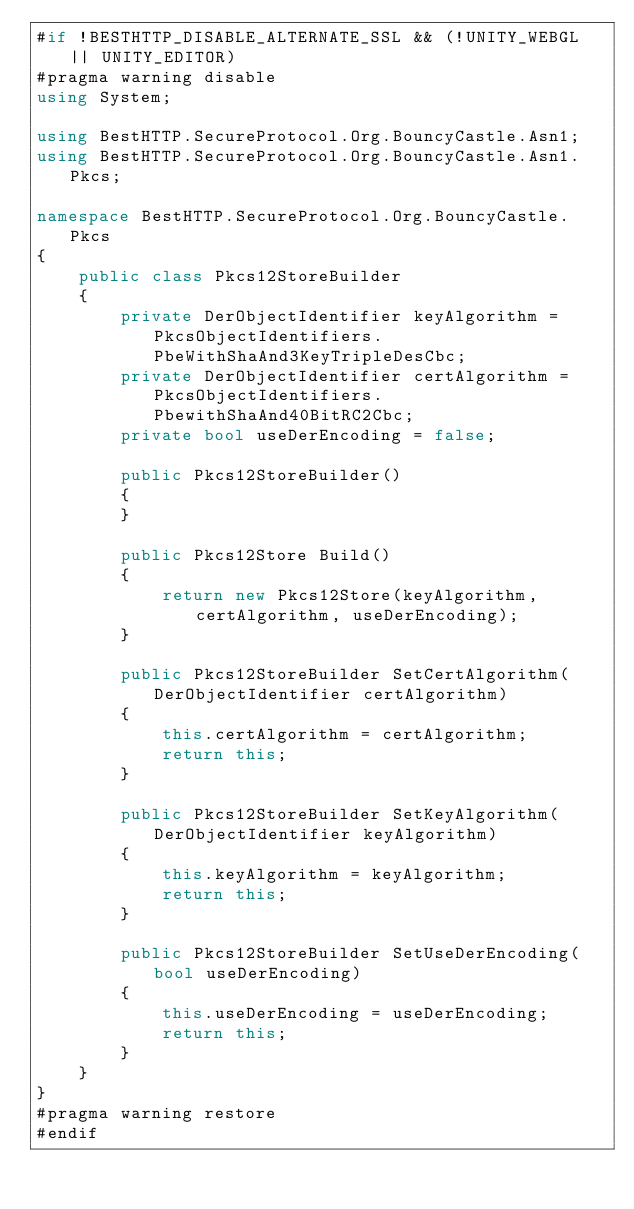<code> <loc_0><loc_0><loc_500><loc_500><_C#_>#if !BESTHTTP_DISABLE_ALTERNATE_SSL && (!UNITY_WEBGL || UNITY_EDITOR)
#pragma warning disable
using System;

using BestHTTP.SecureProtocol.Org.BouncyCastle.Asn1;
using BestHTTP.SecureProtocol.Org.BouncyCastle.Asn1.Pkcs;

namespace BestHTTP.SecureProtocol.Org.BouncyCastle.Pkcs
{
	public class Pkcs12StoreBuilder
	{
		private DerObjectIdentifier	keyAlgorithm = PkcsObjectIdentifiers.PbeWithShaAnd3KeyTripleDesCbc;
		private DerObjectIdentifier	certAlgorithm = PkcsObjectIdentifiers.PbewithShaAnd40BitRC2Cbc;
		private bool useDerEncoding = false;

		public Pkcs12StoreBuilder()
		{
		}

		public Pkcs12Store Build()
		{
			return new Pkcs12Store(keyAlgorithm, certAlgorithm, useDerEncoding);
		}

		public Pkcs12StoreBuilder SetCertAlgorithm(DerObjectIdentifier certAlgorithm)
		{
			this.certAlgorithm = certAlgorithm;
			return this;
		}

		public Pkcs12StoreBuilder SetKeyAlgorithm(DerObjectIdentifier keyAlgorithm)
		{
			this.keyAlgorithm = keyAlgorithm;
			return this;
		}

		public Pkcs12StoreBuilder SetUseDerEncoding(bool useDerEncoding)
		{
			this.useDerEncoding = useDerEncoding;
			return this;
		}
	}
}
#pragma warning restore
#endif
</code> 